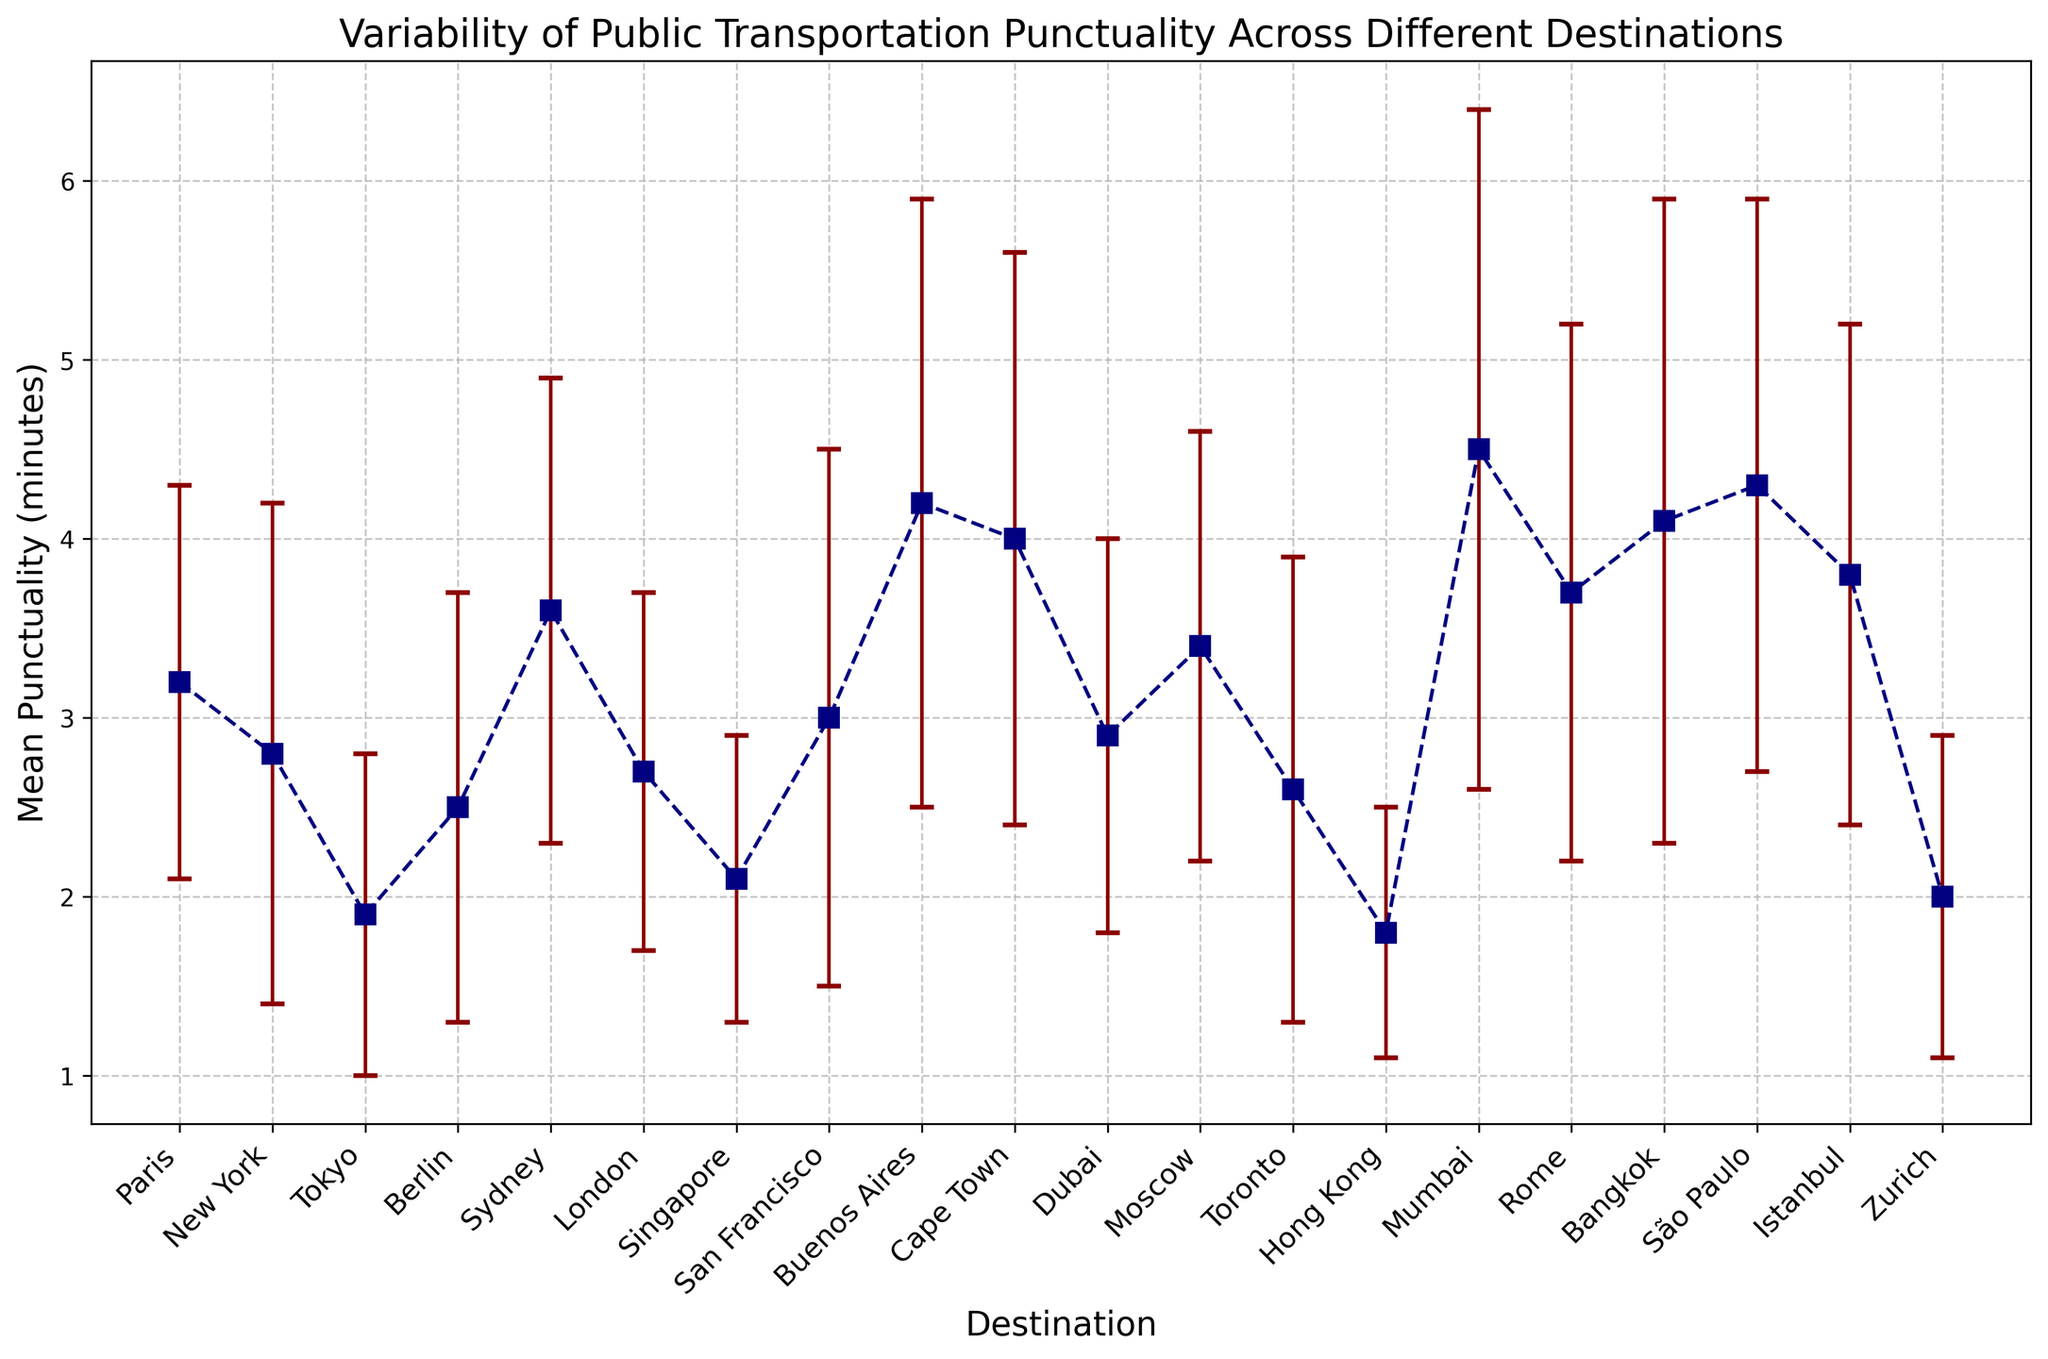What destination has the highest mean punctuality? The destination with the highest mean punctuality will have the tallest data point on the y-axis. By observing the plot, the destination with the highest value on the y-axis corresponds to Mumbai with a mean punctuality of 4.5 minutes.
Answer: Mumbai Which destination has the smallest error bar? The error bar indicates the standard deviation of punctuality. The smallest error bar will be the shortest line extending above and below the data point. By observation, Hong Kong has the smallest error bar.
Answer: Hong Kong Is the mean punctuality in Sydney greater than in London? To determine this, compare the height of the points for Sydney and London on the y-axis. Sydney’s data point is higher at 3.6 minutes compared to London’s 2.7 minutes.
Answer: Yes What's the mean punctuality for Zurich, and how does it compare to Tokyo? First, identify both data points on the y-axis. Zurich has a mean punctuality of 2.0 minutes, and Tokyo has 1.9 minutes, so Zurich is slightly higher.
Answer: Zurich's mean punctuality is 2.0 minutes, and it is slightly higher than Tokyo’s 1.9 minutes Which destination shows the greatest variability in punctuality? The greatest variability is shown by the largest error bar (standard deviation). By observing, Mumbai has the largest error bar of 1.9 minutes.
Answer: Mumbai What is the range of mean punctuality values across all destinations? The range is the difference between the highest and lowest mean punctuality values. The highest mean punctuality is 4.5 minutes in Mumbai, and the lowest is 1.8 minutes in Hong Kong. Therefore, the range is 4.5 - 1.8 = 2.7 minutes.
Answer: 2.7 minutes Which destination has a mean punctuality equal to 3.7 minutes? Look at the y-axis to locate the data point at 3.7 minutes. It corresponds to Rome.
Answer: Rome Are there more destinations with a mean punctuality lower than 3.0 minutes or higher than 3.0 minutes? Count the data points below and above the 3.0 minutes mark. Destinations with mean punctuality lower than 3.0 include New York, Tokyo, London, Singapore, Hong Kong, Dubai, Toronto, and Zurich (8 destinations). Those higher include Paris, Sydney, San Francisco, Buenos Aires, Cape Town, Moscow, Mumbai, Rome, Bangkok, São Paulo, Istanbul (10 destinations).
Answer: Higher than 3.0 minutes 